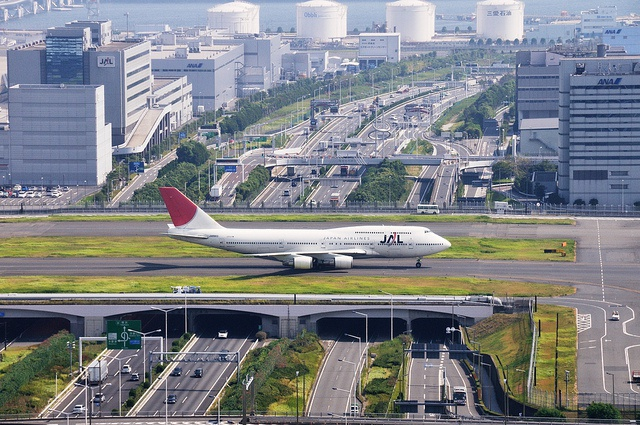Describe the objects in this image and their specific colors. I can see airplane in darkgray, lightgray, gray, and brown tones, car in darkgray, gray, and lightgray tones, truck in darkgray, lightgray, and gray tones, bus in darkgray, black, navy, and gray tones, and bus in darkgray, gray, and white tones in this image. 